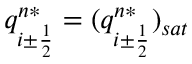<formula> <loc_0><loc_0><loc_500><loc_500>q _ { i \pm \frac { 1 } { 2 } } ^ { n * } = ( q _ { i \pm \frac { 1 } { 2 } } ^ { n * } ) _ { s a t }</formula> 